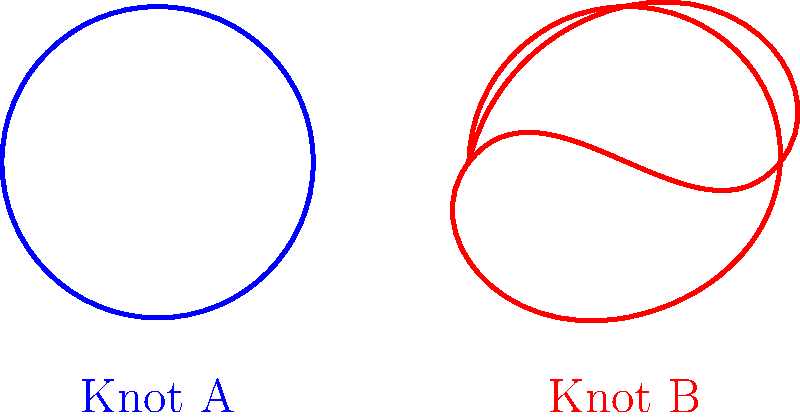Your reggaeton headphones are tangled, forming two distinct knots as shown above. Knot A resembles a trefoil knot, while Knot B is similar to a figure-eight knot. Which of these knots has a higher crossing number, and how does this relate to the difficulty of untangling your headphones before your next performance? Let's break this down step-by-step:

1. Crossing number: This is the minimum number of crossings that occur in any projection of a knot onto a plane.

2. Trefoil knot (Knot A):
   - The trefoil knot has a crossing number of 3.
   - It's the simplest non-trivial knot.

3. Figure-eight knot (Knot B):
   - The figure-eight knot has a crossing number of 4.
   - It's the next simplest knot after the trefoil.

4. Comparison:
   - Knot B (figure-eight) has a higher crossing number (4) than Knot A (trefoil, 3).

5. Relation to untangling:
   - Generally, knots with higher crossing numbers are more complex and potentially more difficult to untangle.
   - The figure-eight knot (Knot B) would likely be more challenging to undo quickly.

6. Practical implication:
   - As a reggaeton enthusiast preparing for a performance, you'd probably spend more time untangling Knot B.
   - This could potentially delay your pre-show routine or warm-up.

Therefore, Knot B (figure-eight knot) has the higher crossing number and would likely be more troublesome to untangle before your reggaeton performance.
Answer: Knot B (figure-eight knot), crossing number 4 